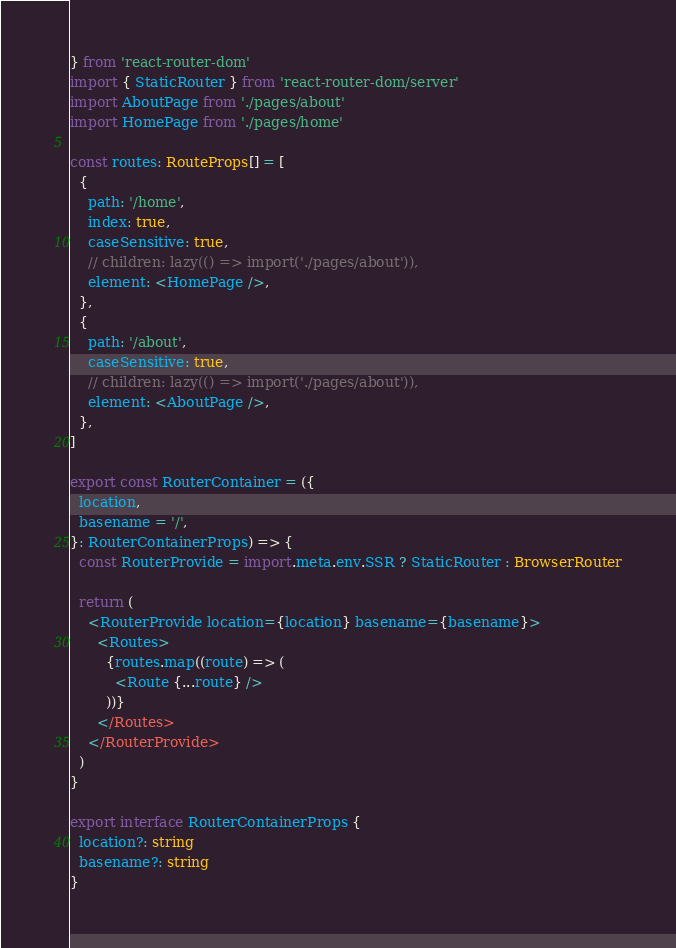Convert code to text. <code><loc_0><loc_0><loc_500><loc_500><_TypeScript_>} from 'react-router-dom'
import { StaticRouter } from 'react-router-dom/server'
import AboutPage from './pages/about'
import HomePage from './pages/home'

const routes: RouteProps[] = [
  {
    path: '/home',
    index: true,
    caseSensitive: true,
    // children: lazy(() => import('./pages/about')),
    element: <HomePage />,
  },
  {
    path: '/about',
    caseSensitive: true,
    // children: lazy(() => import('./pages/about')),
    element: <AboutPage />,
  },
]

export const RouterContainer = ({
  location,
  basename = '/',
}: RouterContainerProps) => {
  const RouterProvide = import.meta.env.SSR ? StaticRouter : BrowserRouter

  return (
    <RouterProvide location={location} basename={basename}>
      <Routes>
        {routes.map((route) => (
          <Route {...route} />
        ))}
      </Routes>
    </RouterProvide>
  )
}

export interface RouterContainerProps {
  location?: string
  basename?: string
}
</code> 